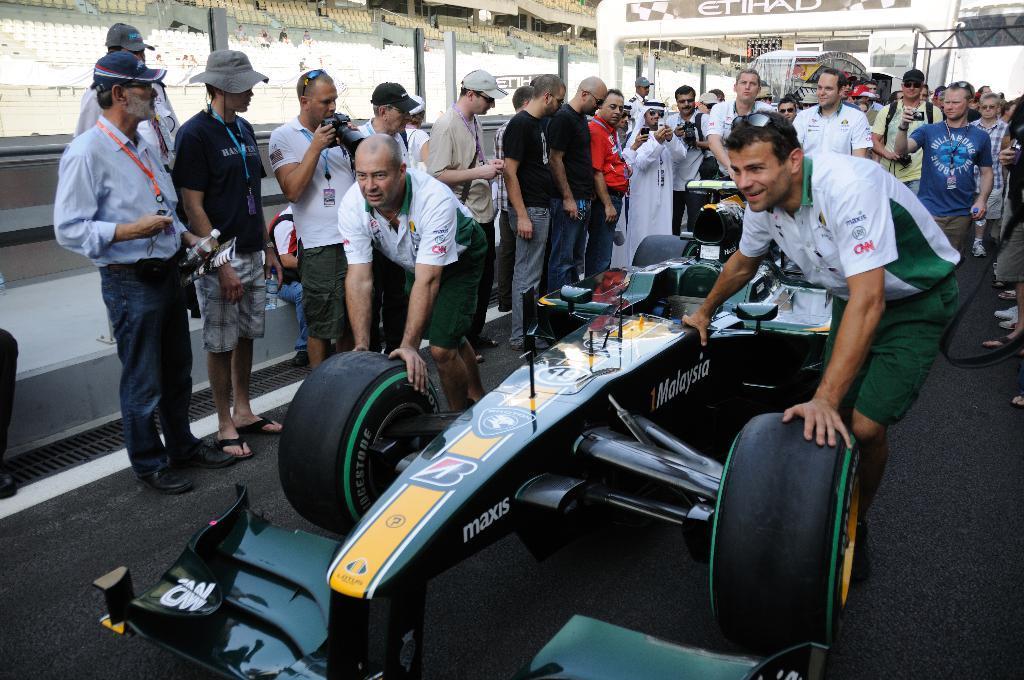Please provide a concise description of this image. In the middle of the image there is a race car and two are pushing the car. And in the background there are few people standing and holding the mobiles and cameras in their hands and taking the picture. At the back of them there are many seats in the ground and also to the top of the image there is a name board. 